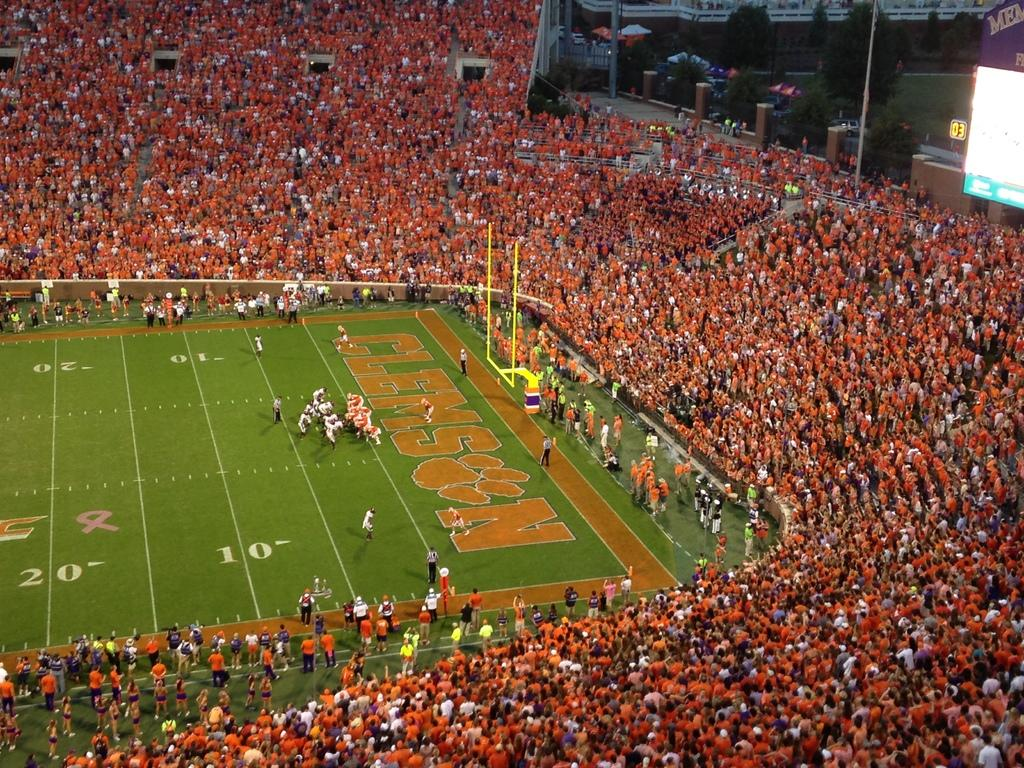What is the main structure visible in the image? There is a stadium in the image. What can be seen inside the stadium? There are groups of people inside the stadium. What is visible in the background of the image? There are trees and buildings in the background of the image. What type of brass instrument can be heard playing in the image? There is no brass instrument or sound present in the image; it only shows a stadium with people inside and trees and buildings in the background. 